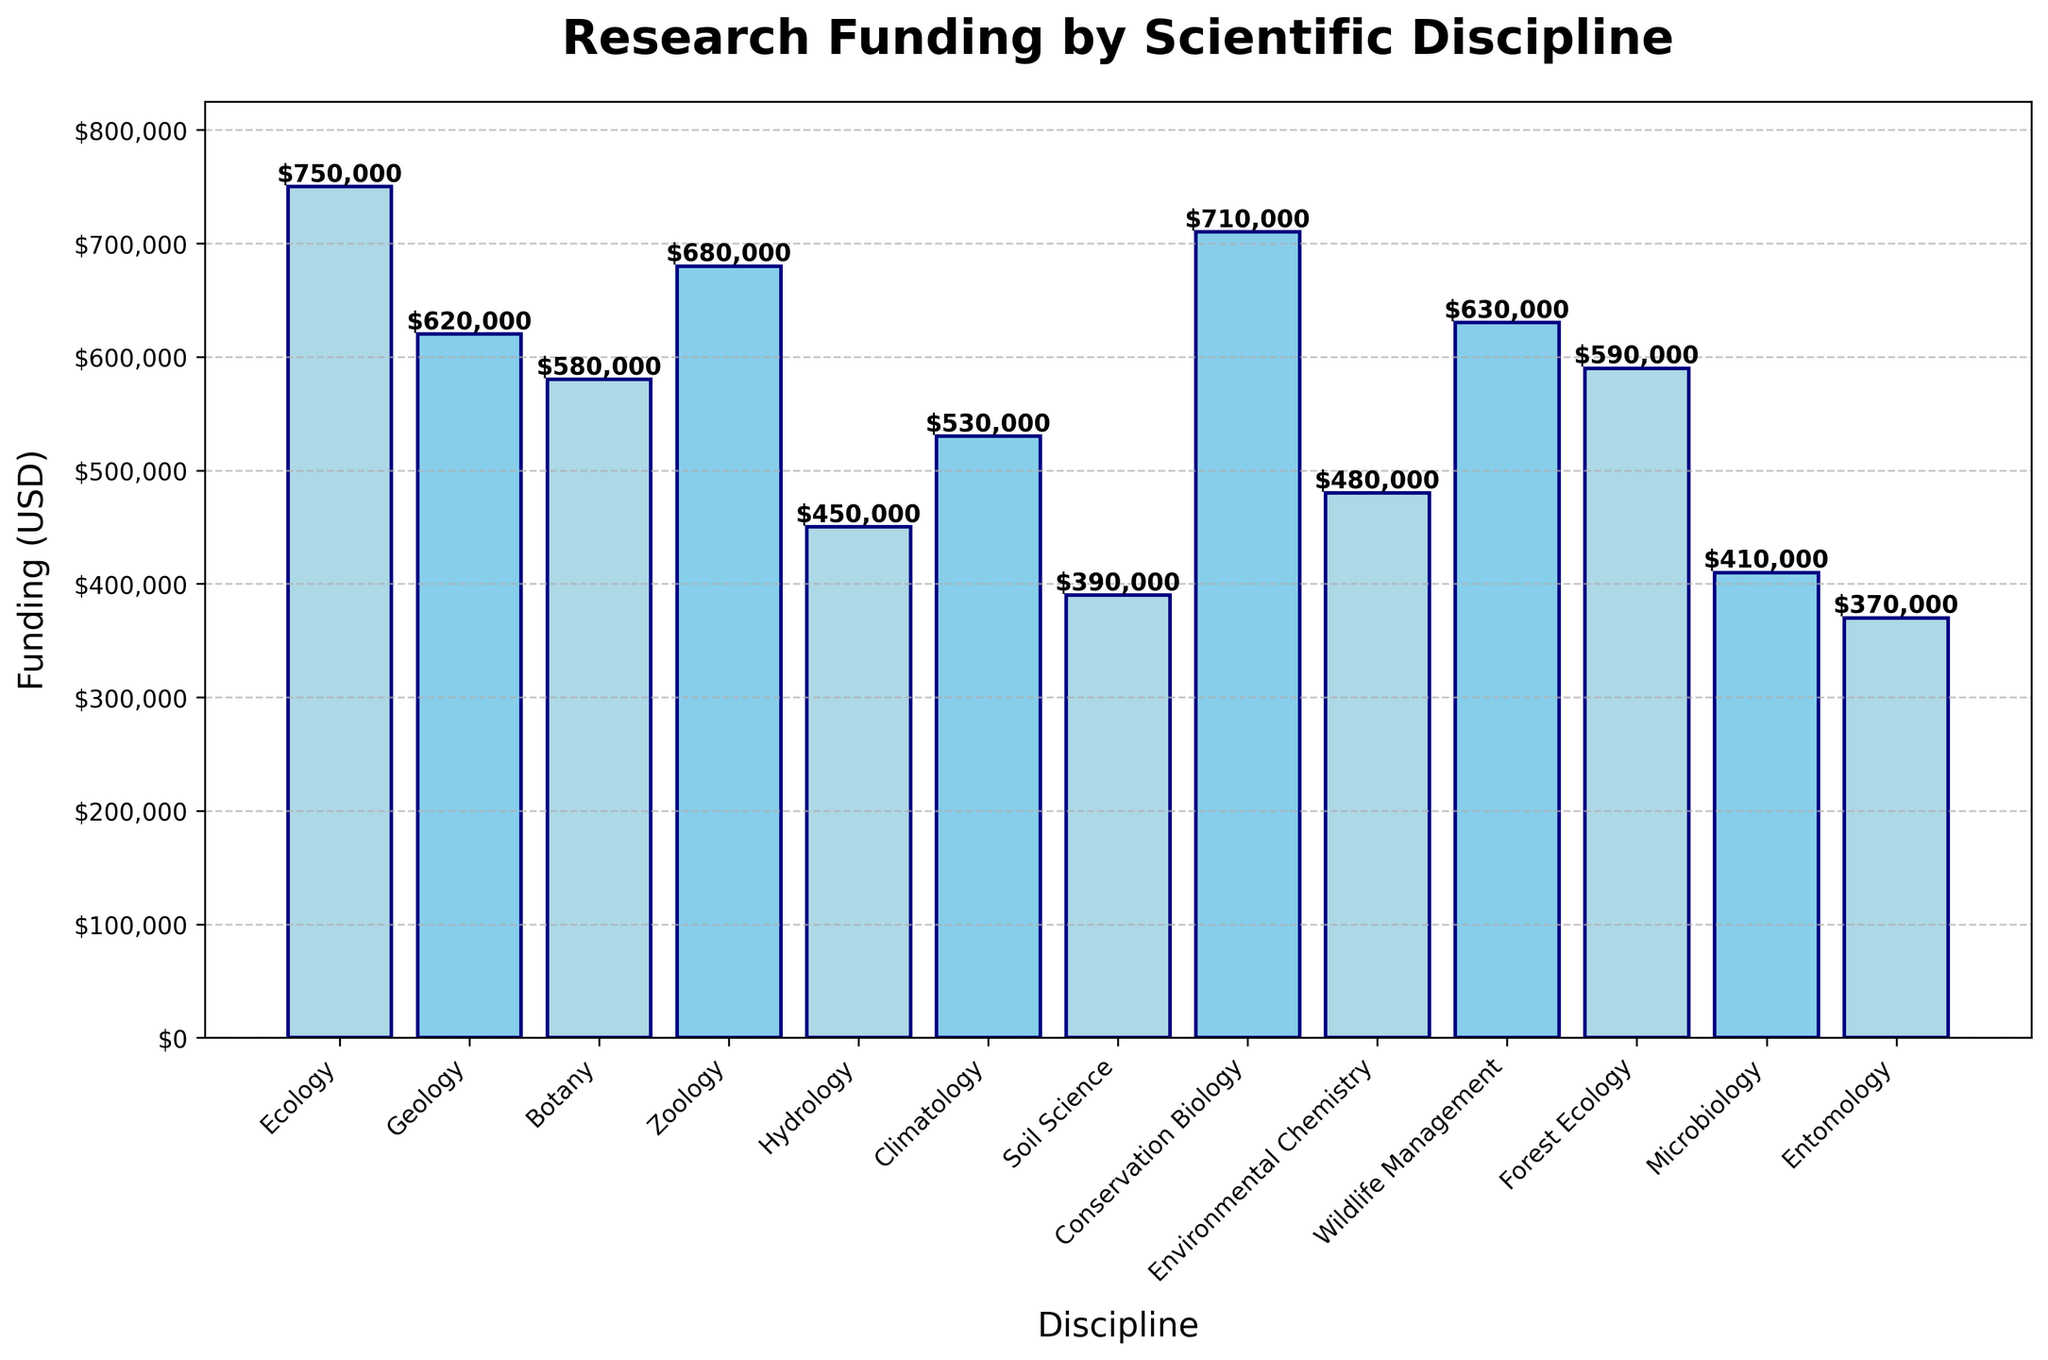Which discipline received the highest amount of funding? The height of each bar represents the funding amount for each discipline. The tallest bar corresponds to Ecology.
Answer: Ecology How much more funding did Zoology receive compared to Botany? The bars for Zoology and Botany represent funding amounts of $680,000 and $580,000 respectively. The difference is calculated as $680,000 - $580,000.
Answer: $100,000 Which disciplines received less funding than Climatology? The bar for Climatology represents $530,000. Disciplines with lower bars and thus less funding include Hydrology, Soil Science, Environmental Chemistry, Microbiology, and Entomology.
Answer: Hydrology, Soil Science, Environmental Chemistry, Microbiology, Entomology What is the total funding received by Ecology, Botany, and Zoology combined? Sum the funding amounts for Ecology ($750,000), Botany ($580,000), and Zoology ($680,000). The total is $750,000 + $580,000 + $680,000.
Answer: $2,010,000 Which discipline's funding is closest to the median value of all the disciplines' funding amounts? First, list all funding amounts: $750,000, $620,000, $580,000, $680,000, $450,000, $530,000, $390,000, $710,000, $480,000, $630,000, $590,000, $410,000, $370,000. In an ordered list, the median is $530,000. Climatology has this exact funding amount.
Answer: Climatology Is the funding for Environmental Chemistry greater or less than the combined funding for Microbiology and Entomology? Environmental Chemistry received $480,000. The combined funding for Microbiology ($410,000) and Entomology ($370,000) is $410,000 + $370,000 = $780,000, which is more than $480,000.
Answer: Less How much is the second-largest funding compared to the smallest funding? The second-largest funding is Conservation Biology ($710,000) and the smallest is Entomology ($370,000). The difference is $710,000 - $370,000.
Answer: $340,000 Which disciplines have funding numbers that are equal? All funding amounts are unique based on the provided data. Thus, no disciplines have equal funding amounts.
Answer: None What is the average funding amount across all disciplines? Sum all funding amounts: $750,000, $620,000, $580,000, $680,000, $450,000, $530,000, $390,000, $710,000, $480,000, $630,000, $590,000, $410,000, $370,000. The total is $7,190,000. There are 13 disciplines, so the average is $7,190,000 / 13.
Answer: $553,846 Is the funding for Soil Science more than that for Microbiology and Entomology combined? Soil Science received $390,000. The combined funding for Microbiology ($410,000) and Entomology ($370,000) is $410,000 + $370,000 = $780,000, which is more than $390,000.
Answer: No 